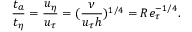<formula> <loc_0><loc_0><loc_500><loc_500>\frac { t _ { a } } { t _ { \eta } } = \frac { u _ { \eta } } { u _ { \tau } } = ( \frac { \nu } { u _ { \tau } h } ) ^ { 1 / 4 } = R e _ { \tau } ^ { - 1 / 4 } .</formula> 